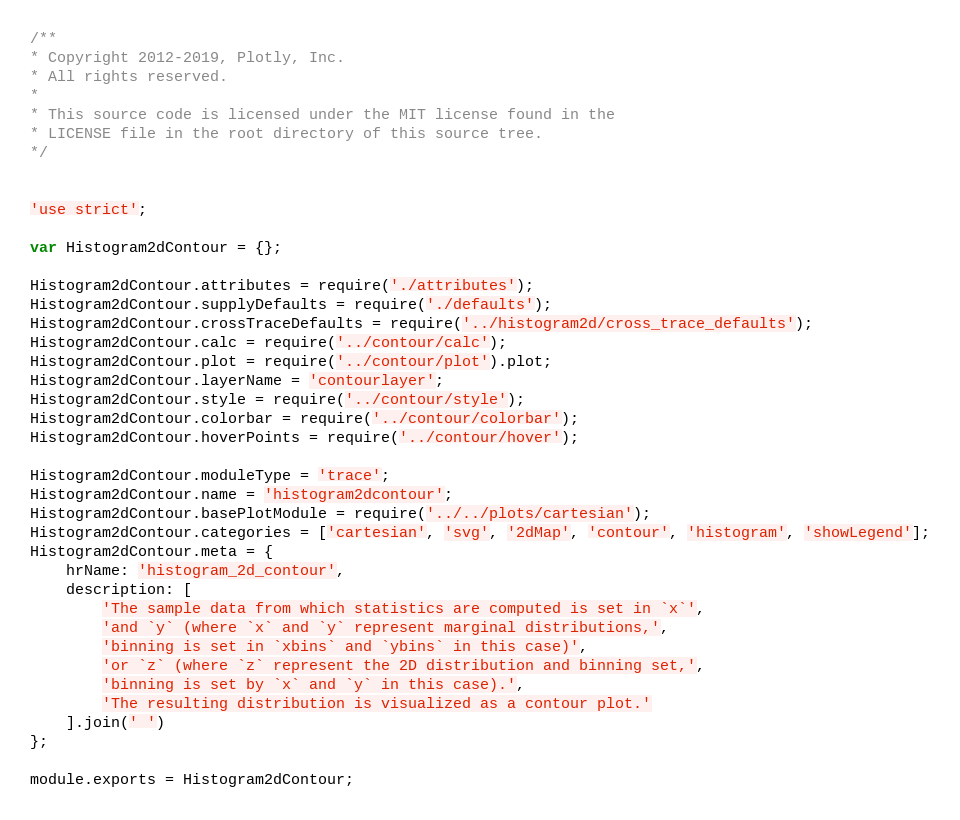Convert code to text. <code><loc_0><loc_0><loc_500><loc_500><_JavaScript_>/**
* Copyright 2012-2019, Plotly, Inc.
* All rights reserved.
*
* This source code is licensed under the MIT license found in the
* LICENSE file in the root directory of this source tree.
*/


'use strict';

var Histogram2dContour = {};

Histogram2dContour.attributes = require('./attributes');
Histogram2dContour.supplyDefaults = require('./defaults');
Histogram2dContour.crossTraceDefaults = require('../histogram2d/cross_trace_defaults');
Histogram2dContour.calc = require('../contour/calc');
Histogram2dContour.plot = require('../contour/plot').plot;
Histogram2dContour.layerName = 'contourlayer';
Histogram2dContour.style = require('../contour/style');
Histogram2dContour.colorbar = require('../contour/colorbar');
Histogram2dContour.hoverPoints = require('../contour/hover');

Histogram2dContour.moduleType = 'trace';
Histogram2dContour.name = 'histogram2dcontour';
Histogram2dContour.basePlotModule = require('../../plots/cartesian');
Histogram2dContour.categories = ['cartesian', 'svg', '2dMap', 'contour', 'histogram', 'showLegend'];
Histogram2dContour.meta = {
    hrName: 'histogram_2d_contour',
    description: [
        'The sample data from which statistics are computed is set in `x`',
        'and `y` (where `x` and `y` represent marginal distributions,',
        'binning is set in `xbins` and `ybins` in this case)',
        'or `z` (where `z` represent the 2D distribution and binning set,',
        'binning is set by `x` and `y` in this case).',
        'The resulting distribution is visualized as a contour plot.'
    ].join(' ')
};

module.exports = Histogram2dContour;
</code> 